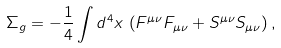Convert formula to latex. <formula><loc_0><loc_0><loc_500><loc_500>\Sigma _ { g } = - \frac { 1 } { 4 } \int d ^ { 4 } x \, \left ( F ^ { \mu \nu } F _ { \mu \nu } + S ^ { \mu \nu } S _ { \mu \nu } \right ) ,</formula> 